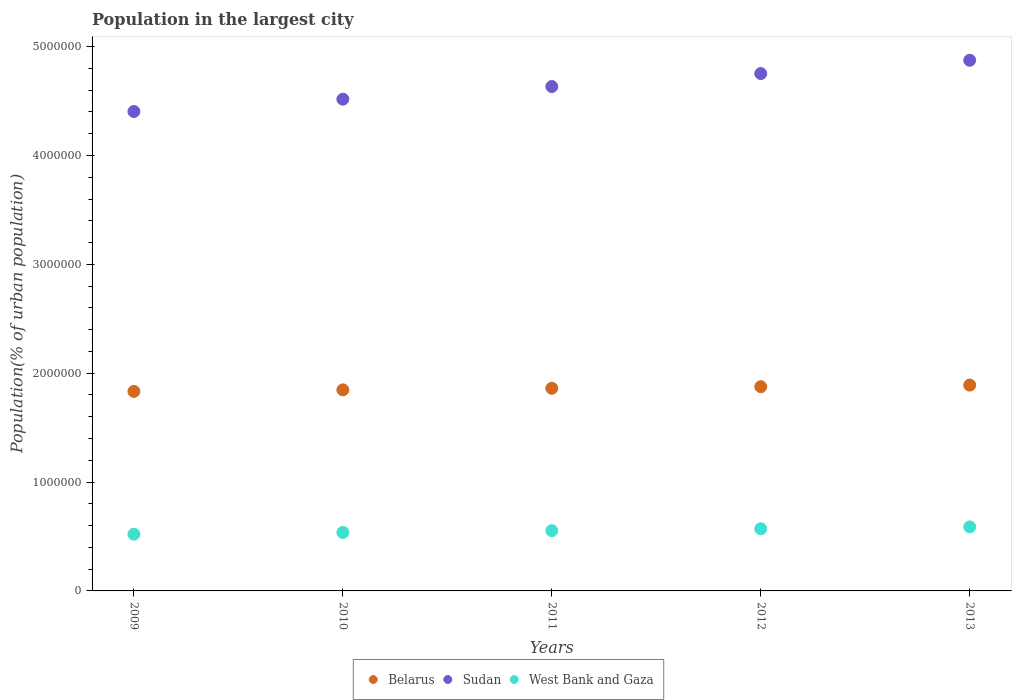How many different coloured dotlines are there?
Your answer should be compact. 3. What is the population in the largest city in West Bank and Gaza in 2012?
Keep it short and to the point. 5.71e+05. Across all years, what is the maximum population in the largest city in West Bank and Gaza?
Provide a succinct answer. 5.88e+05. Across all years, what is the minimum population in the largest city in West Bank and Gaza?
Provide a short and direct response. 5.21e+05. In which year was the population in the largest city in Belarus maximum?
Provide a short and direct response. 2013. In which year was the population in the largest city in West Bank and Gaza minimum?
Make the answer very short. 2009. What is the total population in the largest city in West Bank and Gaza in the graph?
Make the answer very short. 2.77e+06. What is the difference between the population in the largest city in West Bank and Gaza in 2009 and that in 2010?
Your response must be concise. -1.61e+04. What is the difference between the population in the largest city in West Bank and Gaza in 2012 and the population in the largest city in Belarus in 2010?
Make the answer very short. -1.28e+06. What is the average population in the largest city in Belarus per year?
Your answer should be very brief. 1.86e+06. In the year 2012, what is the difference between the population in the largest city in Belarus and population in the largest city in West Bank and Gaza?
Keep it short and to the point. 1.31e+06. What is the ratio of the population in the largest city in Sudan in 2012 to that in 2013?
Your answer should be compact. 0.97. What is the difference between the highest and the second highest population in the largest city in West Bank and Gaza?
Provide a succinct answer. 1.76e+04. What is the difference between the highest and the lowest population in the largest city in West Bank and Gaza?
Your answer should be compact. 6.73e+04. Is the sum of the population in the largest city in Sudan in 2009 and 2013 greater than the maximum population in the largest city in Belarus across all years?
Your answer should be very brief. Yes. Does the population in the largest city in Belarus monotonically increase over the years?
Give a very brief answer. Yes. Is the population in the largest city in Sudan strictly less than the population in the largest city in Belarus over the years?
Your response must be concise. No. How many dotlines are there?
Provide a succinct answer. 3. What is the difference between two consecutive major ticks on the Y-axis?
Make the answer very short. 1.00e+06. Are the values on the major ticks of Y-axis written in scientific E-notation?
Make the answer very short. No. Where does the legend appear in the graph?
Your answer should be compact. Bottom center. What is the title of the graph?
Keep it short and to the point. Population in the largest city. Does "East Asia (all income levels)" appear as one of the legend labels in the graph?
Your answer should be very brief. No. What is the label or title of the Y-axis?
Make the answer very short. Population(% of urban population). What is the Population(% of urban population) in Belarus in 2009?
Give a very brief answer. 1.83e+06. What is the Population(% of urban population) of Sudan in 2009?
Provide a succinct answer. 4.40e+06. What is the Population(% of urban population) in West Bank and Gaza in 2009?
Offer a terse response. 5.21e+05. What is the Population(% of urban population) in Belarus in 2010?
Your answer should be compact. 1.85e+06. What is the Population(% of urban population) in Sudan in 2010?
Offer a terse response. 4.52e+06. What is the Population(% of urban population) in West Bank and Gaza in 2010?
Offer a terse response. 5.37e+05. What is the Population(% of urban population) of Belarus in 2011?
Your answer should be very brief. 1.86e+06. What is the Population(% of urban population) in Sudan in 2011?
Provide a short and direct response. 4.63e+06. What is the Population(% of urban population) in West Bank and Gaza in 2011?
Offer a terse response. 5.54e+05. What is the Population(% of urban population) in Belarus in 2012?
Your answer should be very brief. 1.88e+06. What is the Population(% of urban population) of Sudan in 2012?
Provide a short and direct response. 4.75e+06. What is the Population(% of urban population) of West Bank and Gaza in 2012?
Ensure brevity in your answer.  5.71e+05. What is the Population(% of urban population) in Belarus in 2013?
Your answer should be very brief. 1.89e+06. What is the Population(% of urban population) of Sudan in 2013?
Your answer should be very brief. 4.87e+06. What is the Population(% of urban population) in West Bank and Gaza in 2013?
Ensure brevity in your answer.  5.88e+05. Across all years, what is the maximum Population(% of urban population) of Belarus?
Offer a terse response. 1.89e+06. Across all years, what is the maximum Population(% of urban population) of Sudan?
Your answer should be very brief. 4.87e+06. Across all years, what is the maximum Population(% of urban population) of West Bank and Gaza?
Offer a terse response. 5.88e+05. Across all years, what is the minimum Population(% of urban population) in Belarus?
Your response must be concise. 1.83e+06. Across all years, what is the minimum Population(% of urban population) of Sudan?
Your answer should be compact. 4.40e+06. Across all years, what is the minimum Population(% of urban population) in West Bank and Gaza?
Offer a terse response. 5.21e+05. What is the total Population(% of urban population) in Belarus in the graph?
Make the answer very short. 9.31e+06. What is the total Population(% of urban population) of Sudan in the graph?
Your answer should be very brief. 2.32e+07. What is the total Population(% of urban population) in West Bank and Gaza in the graph?
Offer a terse response. 2.77e+06. What is the difference between the Population(% of urban population) in Belarus in 2009 and that in 2010?
Your response must be concise. -1.43e+04. What is the difference between the Population(% of urban population) of Sudan in 2009 and that in 2010?
Make the answer very short. -1.13e+05. What is the difference between the Population(% of urban population) in West Bank and Gaza in 2009 and that in 2010?
Your response must be concise. -1.61e+04. What is the difference between the Population(% of urban population) of Belarus in 2009 and that in 2011?
Offer a very short reply. -2.87e+04. What is the difference between the Population(% of urban population) of Sudan in 2009 and that in 2011?
Your response must be concise. -2.29e+05. What is the difference between the Population(% of urban population) in West Bank and Gaza in 2009 and that in 2011?
Your answer should be compact. -3.26e+04. What is the difference between the Population(% of urban population) of Belarus in 2009 and that in 2012?
Make the answer very short. -4.32e+04. What is the difference between the Population(% of urban population) in Sudan in 2009 and that in 2012?
Make the answer very short. -3.48e+05. What is the difference between the Population(% of urban population) of West Bank and Gaza in 2009 and that in 2012?
Provide a short and direct response. -4.97e+04. What is the difference between the Population(% of urban population) of Belarus in 2009 and that in 2013?
Provide a succinct answer. -5.78e+04. What is the difference between the Population(% of urban population) in Sudan in 2009 and that in 2013?
Keep it short and to the point. -4.71e+05. What is the difference between the Population(% of urban population) of West Bank and Gaza in 2009 and that in 2013?
Provide a succinct answer. -6.73e+04. What is the difference between the Population(% of urban population) of Belarus in 2010 and that in 2011?
Provide a short and direct response. -1.44e+04. What is the difference between the Population(% of urban population) of Sudan in 2010 and that in 2011?
Your response must be concise. -1.16e+05. What is the difference between the Population(% of urban population) in West Bank and Gaza in 2010 and that in 2011?
Give a very brief answer. -1.66e+04. What is the difference between the Population(% of urban population) of Belarus in 2010 and that in 2012?
Keep it short and to the point. -2.89e+04. What is the difference between the Population(% of urban population) in Sudan in 2010 and that in 2012?
Give a very brief answer. -2.35e+05. What is the difference between the Population(% of urban population) of West Bank and Gaza in 2010 and that in 2012?
Give a very brief answer. -3.37e+04. What is the difference between the Population(% of urban population) of Belarus in 2010 and that in 2013?
Offer a very short reply. -4.35e+04. What is the difference between the Population(% of urban population) of Sudan in 2010 and that in 2013?
Offer a terse response. -3.57e+05. What is the difference between the Population(% of urban population) of West Bank and Gaza in 2010 and that in 2013?
Provide a short and direct response. -5.12e+04. What is the difference between the Population(% of urban population) of Belarus in 2011 and that in 2012?
Your response must be concise. -1.45e+04. What is the difference between the Population(% of urban population) in Sudan in 2011 and that in 2012?
Keep it short and to the point. -1.19e+05. What is the difference between the Population(% of urban population) of West Bank and Gaza in 2011 and that in 2012?
Keep it short and to the point. -1.71e+04. What is the difference between the Population(% of urban population) in Belarus in 2011 and that in 2013?
Offer a terse response. -2.91e+04. What is the difference between the Population(% of urban population) of Sudan in 2011 and that in 2013?
Provide a succinct answer. -2.41e+05. What is the difference between the Population(% of urban population) in West Bank and Gaza in 2011 and that in 2013?
Your answer should be very brief. -3.47e+04. What is the difference between the Population(% of urban population) of Belarus in 2012 and that in 2013?
Offer a very short reply. -1.46e+04. What is the difference between the Population(% of urban population) in Sudan in 2012 and that in 2013?
Provide a short and direct response. -1.22e+05. What is the difference between the Population(% of urban population) of West Bank and Gaza in 2012 and that in 2013?
Your response must be concise. -1.76e+04. What is the difference between the Population(% of urban population) in Belarus in 2009 and the Population(% of urban population) in Sudan in 2010?
Offer a terse response. -2.68e+06. What is the difference between the Population(% of urban population) of Belarus in 2009 and the Population(% of urban population) of West Bank and Gaza in 2010?
Keep it short and to the point. 1.30e+06. What is the difference between the Population(% of urban population) of Sudan in 2009 and the Population(% of urban population) of West Bank and Gaza in 2010?
Your answer should be very brief. 3.87e+06. What is the difference between the Population(% of urban population) in Belarus in 2009 and the Population(% of urban population) in Sudan in 2011?
Your answer should be compact. -2.80e+06. What is the difference between the Population(% of urban population) in Belarus in 2009 and the Population(% of urban population) in West Bank and Gaza in 2011?
Your answer should be very brief. 1.28e+06. What is the difference between the Population(% of urban population) in Sudan in 2009 and the Population(% of urban population) in West Bank and Gaza in 2011?
Provide a succinct answer. 3.85e+06. What is the difference between the Population(% of urban population) of Belarus in 2009 and the Population(% of urban population) of Sudan in 2012?
Keep it short and to the point. -2.92e+06. What is the difference between the Population(% of urban population) in Belarus in 2009 and the Population(% of urban population) in West Bank and Gaza in 2012?
Make the answer very short. 1.26e+06. What is the difference between the Population(% of urban population) of Sudan in 2009 and the Population(% of urban population) of West Bank and Gaza in 2012?
Make the answer very short. 3.83e+06. What is the difference between the Population(% of urban population) in Belarus in 2009 and the Population(% of urban population) in Sudan in 2013?
Make the answer very short. -3.04e+06. What is the difference between the Population(% of urban population) of Belarus in 2009 and the Population(% of urban population) of West Bank and Gaza in 2013?
Your response must be concise. 1.24e+06. What is the difference between the Population(% of urban population) in Sudan in 2009 and the Population(% of urban population) in West Bank and Gaza in 2013?
Give a very brief answer. 3.82e+06. What is the difference between the Population(% of urban population) in Belarus in 2010 and the Population(% of urban population) in Sudan in 2011?
Your answer should be very brief. -2.79e+06. What is the difference between the Population(% of urban population) in Belarus in 2010 and the Population(% of urban population) in West Bank and Gaza in 2011?
Your answer should be compact. 1.29e+06. What is the difference between the Population(% of urban population) in Sudan in 2010 and the Population(% of urban population) in West Bank and Gaza in 2011?
Make the answer very short. 3.96e+06. What is the difference between the Population(% of urban population) of Belarus in 2010 and the Population(% of urban population) of Sudan in 2012?
Make the answer very short. -2.91e+06. What is the difference between the Population(% of urban population) in Belarus in 2010 and the Population(% of urban population) in West Bank and Gaza in 2012?
Keep it short and to the point. 1.28e+06. What is the difference between the Population(% of urban population) in Sudan in 2010 and the Population(% of urban population) in West Bank and Gaza in 2012?
Offer a very short reply. 3.95e+06. What is the difference between the Population(% of urban population) in Belarus in 2010 and the Population(% of urban population) in Sudan in 2013?
Ensure brevity in your answer.  -3.03e+06. What is the difference between the Population(% of urban population) of Belarus in 2010 and the Population(% of urban population) of West Bank and Gaza in 2013?
Offer a very short reply. 1.26e+06. What is the difference between the Population(% of urban population) in Sudan in 2010 and the Population(% of urban population) in West Bank and Gaza in 2013?
Provide a short and direct response. 3.93e+06. What is the difference between the Population(% of urban population) in Belarus in 2011 and the Population(% of urban population) in Sudan in 2012?
Your answer should be very brief. -2.89e+06. What is the difference between the Population(% of urban population) of Belarus in 2011 and the Population(% of urban population) of West Bank and Gaza in 2012?
Offer a terse response. 1.29e+06. What is the difference between the Population(% of urban population) of Sudan in 2011 and the Population(% of urban population) of West Bank and Gaza in 2012?
Your response must be concise. 4.06e+06. What is the difference between the Population(% of urban population) in Belarus in 2011 and the Population(% of urban population) in Sudan in 2013?
Offer a terse response. -3.01e+06. What is the difference between the Population(% of urban population) of Belarus in 2011 and the Population(% of urban population) of West Bank and Gaza in 2013?
Provide a succinct answer. 1.27e+06. What is the difference between the Population(% of urban population) of Sudan in 2011 and the Population(% of urban population) of West Bank and Gaza in 2013?
Offer a terse response. 4.04e+06. What is the difference between the Population(% of urban population) in Belarus in 2012 and the Population(% of urban population) in Sudan in 2013?
Provide a short and direct response. -3.00e+06. What is the difference between the Population(% of urban population) of Belarus in 2012 and the Population(% of urban population) of West Bank and Gaza in 2013?
Offer a terse response. 1.29e+06. What is the difference between the Population(% of urban population) of Sudan in 2012 and the Population(% of urban population) of West Bank and Gaza in 2013?
Offer a very short reply. 4.16e+06. What is the average Population(% of urban population) in Belarus per year?
Your answer should be compact. 1.86e+06. What is the average Population(% of urban population) in Sudan per year?
Your answer should be very brief. 4.64e+06. What is the average Population(% of urban population) of West Bank and Gaza per year?
Ensure brevity in your answer.  5.54e+05. In the year 2009, what is the difference between the Population(% of urban population) in Belarus and Population(% of urban population) in Sudan?
Your answer should be very brief. -2.57e+06. In the year 2009, what is the difference between the Population(% of urban population) in Belarus and Population(% of urban population) in West Bank and Gaza?
Provide a short and direct response. 1.31e+06. In the year 2009, what is the difference between the Population(% of urban population) in Sudan and Population(% of urban population) in West Bank and Gaza?
Provide a short and direct response. 3.88e+06. In the year 2010, what is the difference between the Population(% of urban population) in Belarus and Population(% of urban population) in Sudan?
Your answer should be very brief. -2.67e+06. In the year 2010, what is the difference between the Population(% of urban population) in Belarus and Population(% of urban population) in West Bank and Gaza?
Your answer should be very brief. 1.31e+06. In the year 2010, what is the difference between the Population(% of urban population) of Sudan and Population(% of urban population) of West Bank and Gaza?
Your answer should be compact. 3.98e+06. In the year 2011, what is the difference between the Population(% of urban population) in Belarus and Population(% of urban population) in Sudan?
Offer a terse response. -2.77e+06. In the year 2011, what is the difference between the Population(% of urban population) in Belarus and Population(% of urban population) in West Bank and Gaza?
Provide a succinct answer. 1.31e+06. In the year 2011, what is the difference between the Population(% of urban population) of Sudan and Population(% of urban population) of West Bank and Gaza?
Your response must be concise. 4.08e+06. In the year 2012, what is the difference between the Population(% of urban population) in Belarus and Population(% of urban population) in Sudan?
Ensure brevity in your answer.  -2.88e+06. In the year 2012, what is the difference between the Population(% of urban population) in Belarus and Population(% of urban population) in West Bank and Gaza?
Your answer should be compact. 1.31e+06. In the year 2012, what is the difference between the Population(% of urban population) of Sudan and Population(% of urban population) of West Bank and Gaza?
Offer a terse response. 4.18e+06. In the year 2013, what is the difference between the Population(% of urban population) of Belarus and Population(% of urban population) of Sudan?
Your answer should be compact. -2.98e+06. In the year 2013, what is the difference between the Population(% of urban population) in Belarus and Population(% of urban population) in West Bank and Gaza?
Your response must be concise. 1.30e+06. In the year 2013, what is the difference between the Population(% of urban population) in Sudan and Population(% of urban population) in West Bank and Gaza?
Provide a short and direct response. 4.29e+06. What is the ratio of the Population(% of urban population) in Belarus in 2009 to that in 2010?
Your answer should be compact. 0.99. What is the ratio of the Population(% of urban population) in Sudan in 2009 to that in 2010?
Offer a very short reply. 0.97. What is the ratio of the Population(% of urban population) in West Bank and Gaza in 2009 to that in 2010?
Make the answer very short. 0.97. What is the ratio of the Population(% of urban population) of Belarus in 2009 to that in 2011?
Offer a very short reply. 0.98. What is the ratio of the Population(% of urban population) of Sudan in 2009 to that in 2011?
Give a very brief answer. 0.95. What is the ratio of the Population(% of urban population) of West Bank and Gaza in 2009 to that in 2011?
Your answer should be compact. 0.94. What is the ratio of the Population(% of urban population) of Belarus in 2009 to that in 2012?
Give a very brief answer. 0.98. What is the ratio of the Population(% of urban population) of Sudan in 2009 to that in 2012?
Provide a succinct answer. 0.93. What is the ratio of the Population(% of urban population) in West Bank and Gaza in 2009 to that in 2012?
Offer a terse response. 0.91. What is the ratio of the Population(% of urban population) of Belarus in 2009 to that in 2013?
Offer a very short reply. 0.97. What is the ratio of the Population(% of urban population) in Sudan in 2009 to that in 2013?
Offer a very short reply. 0.9. What is the ratio of the Population(% of urban population) in West Bank and Gaza in 2009 to that in 2013?
Offer a very short reply. 0.89. What is the ratio of the Population(% of urban population) of Sudan in 2010 to that in 2011?
Offer a terse response. 0.97. What is the ratio of the Population(% of urban population) of West Bank and Gaza in 2010 to that in 2011?
Your answer should be compact. 0.97. What is the ratio of the Population(% of urban population) in Belarus in 2010 to that in 2012?
Provide a short and direct response. 0.98. What is the ratio of the Population(% of urban population) in Sudan in 2010 to that in 2012?
Your answer should be very brief. 0.95. What is the ratio of the Population(% of urban population) of West Bank and Gaza in 2010 to that in 2012?
Offer a terse response. 0.94. What is the ratio of the Population(% of urban population) of Belarus in 2010 to that in 2013?
Provide a short and direct response. 0.98. What is the ratio of the Population(% of urban population) in Sudan in 2010 to that in 2013?
Provide a succinct answer. 0.93. What is the ratio of the Population(% of urban population) in West Bank and Gaza in 2010 to that in 2013?
Your response must be concise. 0.91. What is the ratio of the Population(% of urban population) of Sudan in 2011 to that in 2012?
Provide a short and direct response. 0.97. What is the ratio of the Population(% of urban population) of West Bank and Gaza in 2011 to that in 2012?
Offer a terse response. 0.97. What is the ratio of the Population(% of urban population) in Belarus in 2011 to that in 2013?
Your answer should be very brief. 0.98. What is the ratio of the Population(% of urban population) in Sudan in 2011 to that in 2013?
Provide a succinct answer. 0.95. What is the ratio of the Population(% of urban population) of West Bank and Gaza in 2011 to that in 2013?
Provide a succinct answer. 0.94. What is the ratio of the Population(% of urban population) in Sudan in 2012 to that in 2013?
Provide a succinct answer. 0.97. What is the ratio of the Population(% of urban population) in West Bank and Gaza in 2012 to that in 2013?
Ensure brevity in your answer.  0.97. What is the difference between the highest and the second highest Population(% of urban population) in Belarus?
Ensure brevity in your answer.  1.46e+04. What is the difference between the highest and the second highest Population(% of urban population) of Sudan?
Make the answer very short. 1.22e+05. What is the difference between the highest and the second highest Population(% of urban population) in West Bank and Gaza?
Your answer should be compact. 1.76e+04. What is the difference between the highest and the lowest Population(% of urban population) of Belarus?
Provide a succinct answer. 5.78e+04. What is the difference between the highest and the lowest Population(% of urban population) in Sudan?
Give a very brief answer. 4.71e+05. What is the difference between the highest and the lowest Population(% of urban population) in West Bank and Gaza?
Your response must be concise. 6.73e+04. 